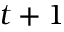Convert formula to latex. <formula><loc_0><loc_0><loc_500><loc_500>t + 1</formula> 